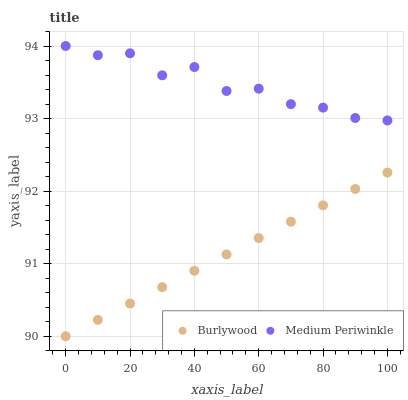Does Burlywood have the minimum area under the curve?
Answer yes or no. Yes. Does Medium Periwinkle have the maximum area under the curve?
Answer yes or no. Yes. Does Medium Periwinkle have the minimum area under the curve?
Answer yes or no. No. Is Burlywood the smoothest?
Answer yes or no. Yes. Is Medium Periwinkle the roughest?
Answer yes or no. Yes. Is Medium Periwinkle the smoothest?
Answer yes or no. No. Does Burlywood have the lowest value?
Answer yes or no. Yes. Does Medium Periwinkle have the lowest value?
Answer yes or no. No. Does Medium Periwinkle have the highest value?
Answer yes or no. Yes. Is Burlywood less than Medium Periwinkle?
Answer yes or no. Yes. Is Medium Periwinkle greater than Burlywood?
Answer yes or no. Yes. Does Burlywood intersect Medium Periwinkle?
Answer yes or no. No. 